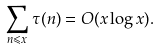Convert formula to latex. <formula><loc_0><loc_0><loc_500><loc_500>\sum _ { n \leqslant x } \tau ( n ) = O ( x \log x ) .</formula> 